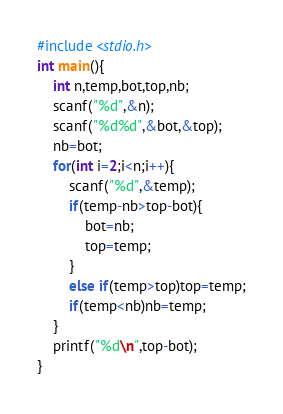<code> <loc_0><loc_0><loc_500><loc_500><_C++_>#include <stdio.h>
int main(){
    int n,temp,bot,top,nb;
    scanf("%d",&n);
    scanf("%d%d",&bot,&top);
    nb=bot;
    for(int i=2;i<n;i++){
        scanf("%d",&temp);
        if(temp-nb>top-bot){
            bot=nb;
            top=temp;
        }
        else if(temp>top)top=temp;
        if(temp<nb)nb=temp;
    }
    printf("%d\n",top-bot);
}</code> 